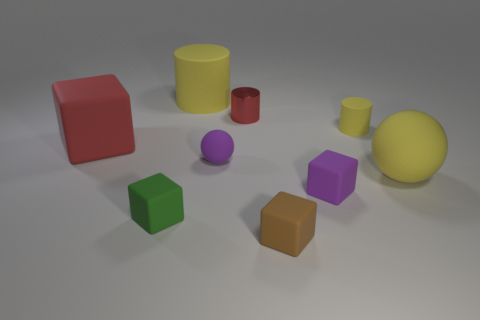Subtract all yellow cylinders. How many cylinders are left? 1 Add 1 tiny green matte things. How many objects exist? 10 Subtract all blue balls. How many yellow cylinders are left? 2 Subtract all purple blocks. How many blocks are left? 3 Subtract all cubes. How many objects are left? 5 Subtract 3 blocks. How many blocks are left? 1 Subtract all big metal spheres. Subtract all rubber cubes. How many objects are left? 5 Add 7 small metal cylinders. How many small metal cylinders are left? 8 Add 3 cyan cubes. How many cyan cubes exist? 3 Subtract 0 red balls. How many objects are left? 9 